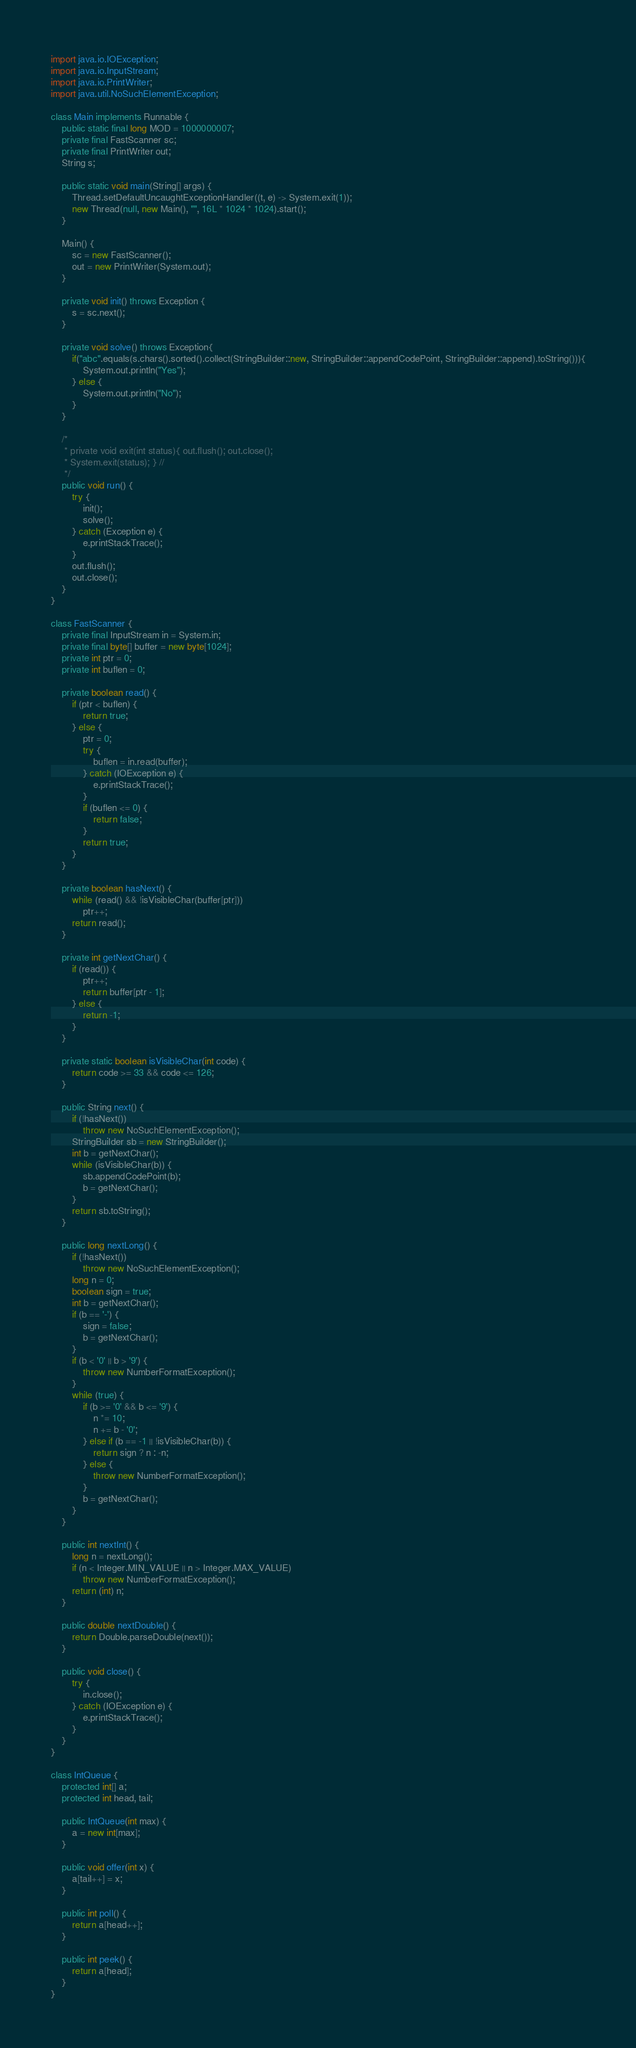<code> <loc_0><loc_0><loc_500><loc_500><_Java_>import java.io.IOException;
import java.io.InputStream;
import java.io.PrintWriter;
import java.util.NoSuchElementException;

class Main implements Runnable {
	public static final long MOD = 1000000007;
	private final FastScanner sc;
	private final PrintWriter out;
	String s;

	public static void main(String[] args) {
		Thread.setDefaultUncaughtExceptionHandler((t, e) -> System.exit(1));
		new Thread(null, new Main(), "", 16L * 1024 * 1024).start();
	}

	Main() {
		sc = new FastScanner();
		out = new PrintWriter(System.out);
	}

	private void init() throws Exception {
		s = sc.next();
	}

	private void solve() throws Exception{
		if("abc".equals(s.chars().sorted().collect(StringBuilder::new, StringBuilder::appendCodePoint, StringBuilder::append).toString())){
			System.out.println("Yes");
		} else {
			System.out.println("No");
		}
	}

	/*
	 * private void exit(int status){ out.flush(); out.close();
	 * System.exit(status); } //
	 */
	public void run() {
		try {
			init();
			solve();
		} catch (Exception e) {
			e.printStackTrace();
		}
		out.flush();
		out.close();
	}
}

class FastScanner {
	private final InputStream in = System.in;
	private final byte[] buffer = new byte[1024];
	private int ptr = 0;
	private int buflen = 0;

	private boolean read() {
		if (ptr < buflen) {
			return true;
		} else {
			ptr = 0;
			try {
				buflen = in.read(buffer);
			} catch (IOException e) {
				e.printStackTrace();
			}
			if (buflen <= 0) {
				return false;
			}
			return true;
		}
	}

	private boolean hasNext() {
		while (read() && !isVisibleChar(buffer[ptr]))
			ptr++;
		return read();
	}

	private int getNextChar() {
		if (read()) {
			ptr++;
			return buffer[ptr - 1];
		} else {
			return -1;
		}
	}

	private static boolean isVisibleChar(int code) {
		return code >= 33 && code <= 126;
	}

	public String next() {
		if (!hasNext())
			throw new NoSuchElementException();
		StringBuilder sb = new StringBuilder();
		int b = getNextChar();
		while (isVisibleChar(b)) {
			sb.appendCodePoint(b);
			b = getNextChar();
		}
		return sb.toString();
	}

	public long nextLong() {
		if (!hasNext())
			throw new NoSuchElementException();
		long n = 0;
		boolean sign = true;
		int b = getNextChar();
		if (b == '-') {
			sign = false;
			b = getNextChar();
		}
		if (b < '0' || b > '9') {
			throw new NumberFormatException();
		}
		while (true) {
			if (b >= '0' && b <= '9') {
				n *= 10;
				n += b - '0';
			} else if (b == -1 || !isVisibleChar(b)) {
				return sign ? n : -n;
			} else {
				throw new NumberFormatException();
			}
			b = getNextChar();
		}
	}

	public int nextInt() {
		long n = nextLong();
		if (n < Integer.MIN_VALUE || n > Integer.MAX_VALUE)
			throw new NumberFormatException();
		return (int) n;
	}

	public double nextDouble() {
		return Double.parseDouble(next());
	}

	public void close() {
		try {
			in.close();
		} catch (IOException e) {
			e.printStackTrace();
		}
	}
}

class IntQueue {
	protected int[] a;
	protected int head, tail;

	public IntQueue(int max) {
		a = new int[max];
	}

	public void offer(int x) {
		a[tail++] = x;
	}

	public int poll() {
		return a[head++];
	}

	public int peek() {
		return a[head];
	}
}
</code> 